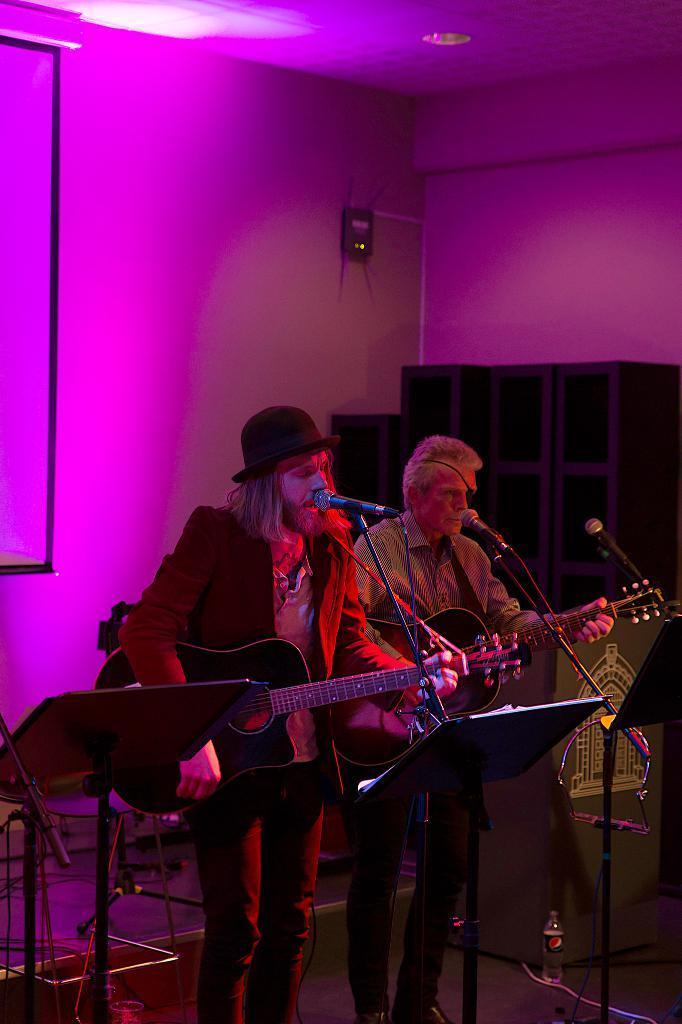Can you describe this image briefly? In this image there are 2 persons standing and playing a guitar , and the back ground there is a screen. 